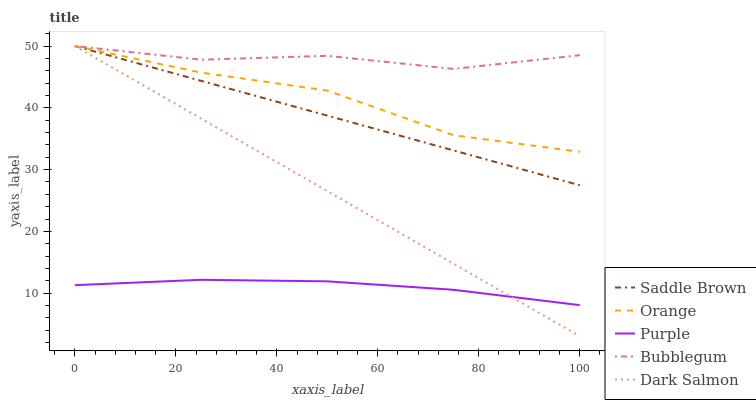Does Purple have the minimum area under the curve?
Answer yes or no. Yes. Does Bubblegum have the maximum area under the curve?
Answer yes or no. Yes. Does Saddle Brown have the minimum area under the curve?
Answer yes or no. No. Does Saddle Brown have the maximum area under the curve?
Answer yes or no. No. Is Dark Salmon the smoothest?
Answer yes or no. Yes. Is Orange the roughest?
Answer yes or no. Yes. Is Purple the smoothest?
Answer yes or no. No. Is Purple the roughest?
Answer yes or no. No. Does Dark Salmon have the lowest value?
Answer yes or no. Yes. Does Purple have the lowest value?
Answer yes or no. No. Does Dark Salmon have the highest value?
Answer yes or no. Yes. Does Purple have the highest value?
Answer yes or no. No. Is Purple less than Bubblegum?
Answer yes or no. Yes. Is Orange greater than Purple?
Answer yes or no. Yes. Does Purple intersect Dark Salmon?
Answer yes or no. Yes. Is Purple less than Dark Salmon?
Answer yes or no. No. Is Purple greater than Dark Salmon?
Answer yes or no. No. Does Purple intersect Bubblegum?
Answer yes or no. No. 